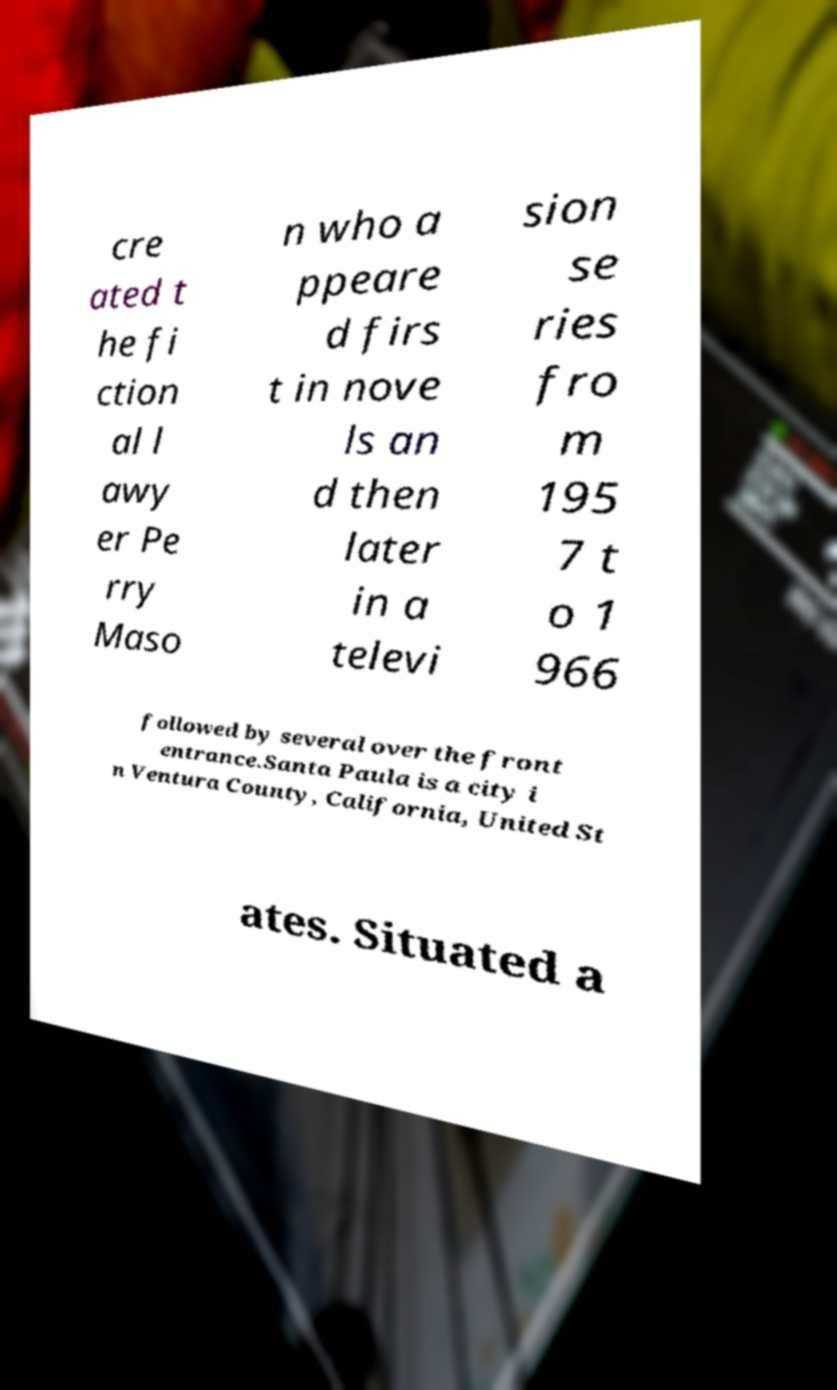Could you assist in decoding the text presented in this image and type it out clearly? cre ated t he fi ction al l awy er Pe rry Maso n who a ppeare d firs t in nove ls an d then later in a televi sion se ries fro m 195 7 t o 1 966 followed by several over the front entrance.Santa Paula is a city i n Ventura County, California, United St ates. Situated a 